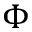Convert formula to latex. <formula><loc_0><loc_0><loc_500><loc_500>\Phi</formula> 